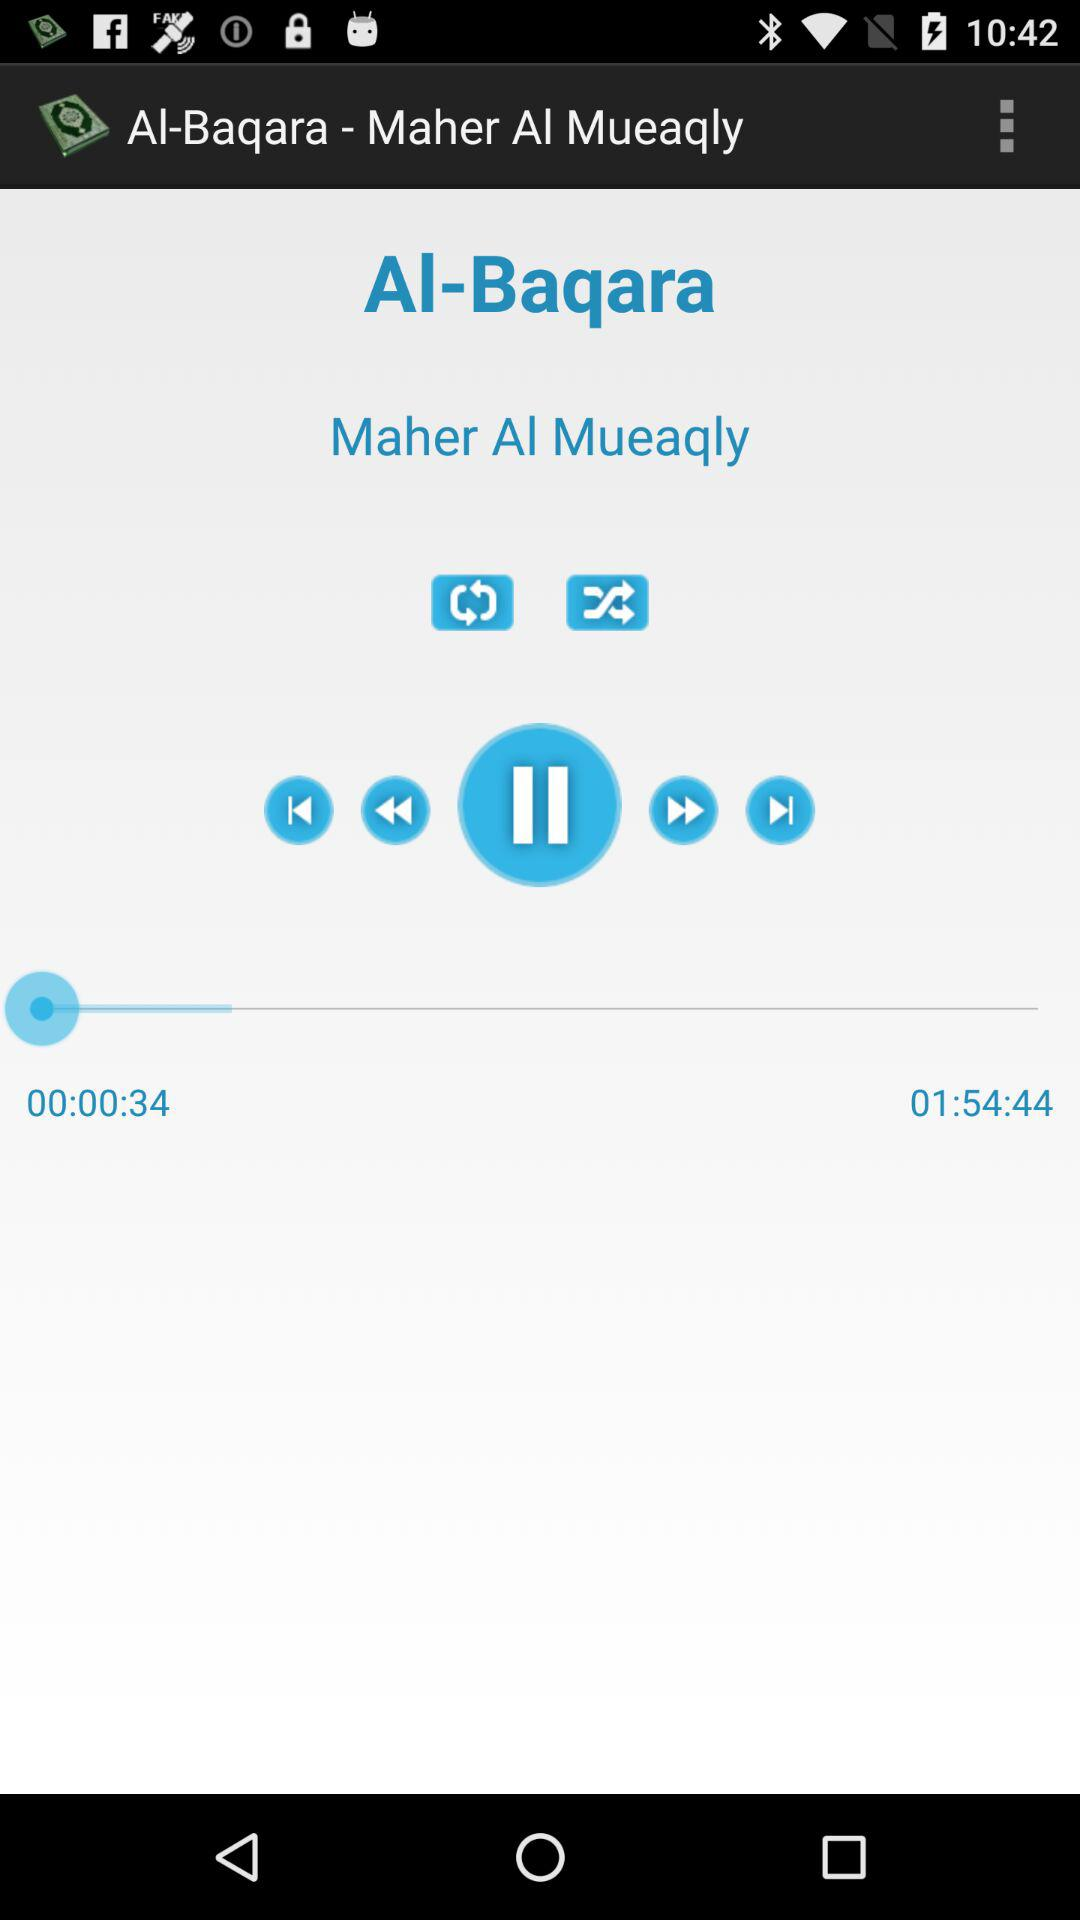What is the time duration of the audio currently being played? The time duration of the audio is 1 hour, 54 minutes and 44 seconds. 